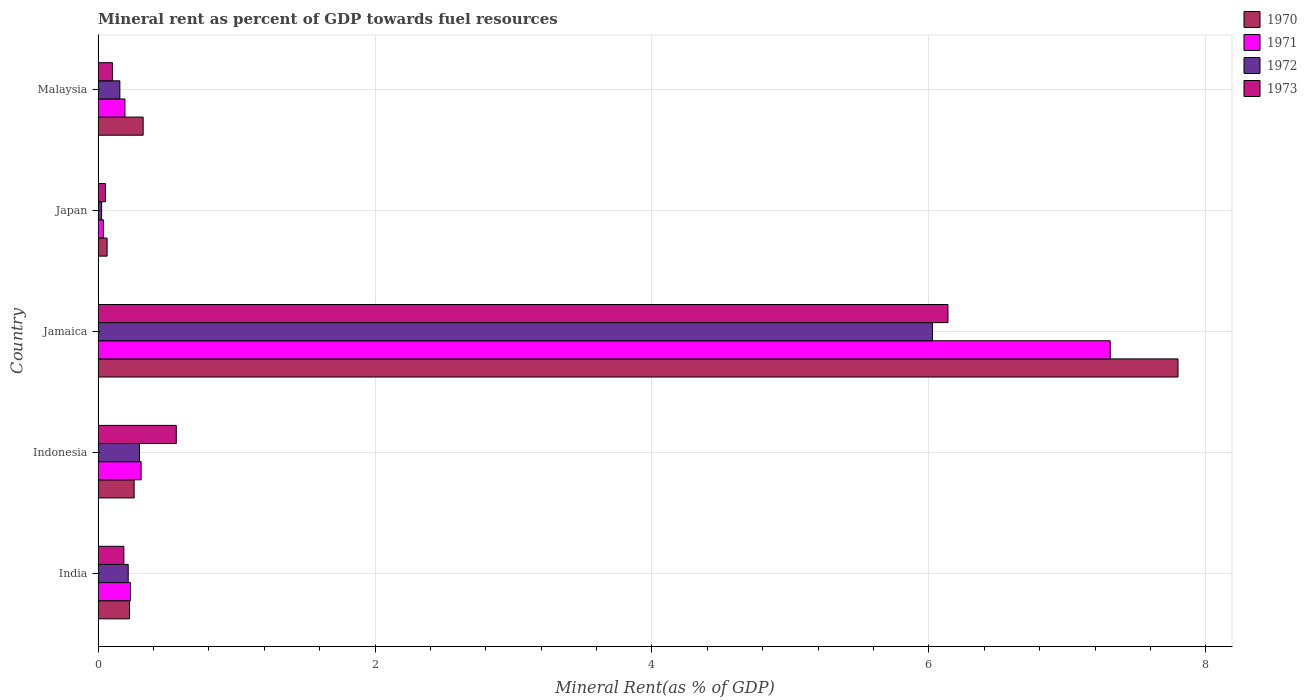How many groups of bars are there?
Your answer should be very brief. 5. Are the number of bars on each tick of the Y-axis equal?
Provide a succinct answer. Yes. How many bars are there on the 2nd tick from the top?
Offer a terse response. 4. What is the mineral rent in 1972 in Indonesia?
Keep it short and to the point. 0.3. Across all countries, what is the maximum mineral rent in 1970?
Keep it short and to the point. 7.8. Across all countries, what is the minimum mineral rent in 1971?
Keep it short and to the point. 0.04. In which country was the mineral rent in 1971 maximum?
Offer a terse response. Jamaica. In which country was the mineral rent in 1973 minimum?
Your answer should be compact. Japan. What is the total mineral rent in 1970 in the graph?
Offer a terse response. 8.68. What is the difference between the mineral rent in 1972 in Indonesia and that in Malaysia?
Your answer should be very brief. 0.14. What is the difference between the mineral rent in 1971 in Jamaica and the mineral rent in 1970 in India?
Your answer should be very brief. 7.08. What is the average mineral rent in 1973 per country?
Your response must be concise. 1.41. What is the difference between the mineral rent in 1972 and mineral rent in 1973 in Jamaica?
Give a very brief answer. -0.11. What is the ratio of the mineral rent in 1970 in India to that in Japan?
Ensure brevity in your answer.  3.5. What is the difference between the highest and the second highest mineral rent in 1972?
Give a very brief answer. 5.73. What is the difference between the highest and the lowest mineral rent in 1970?
Provide a succinct answer. 7.73. Is it the case that in every country, the sum of the mineral rent in 1971 and mineral rent in 1970 is greater than the sum of mineral rent in 1972 and mineral rent in 1973?
Provide a short and direct response. No. What does the 3rd bar from the top in Malaysia represents?
Ensure brevity in your answer.  1971. What does the 3rd bar from the bottom in Japan represents?
Your answer should be compact. 1972. Is it the case that in every country, the sum of the mineral rent in 1971 and mineral rent in 1973 is greater than the mineral rent in 1970?
Make the answer very short. No. How many bars are there?
Offer a terse response. 20. How many countries are there in the graph?
Offer a very short reply. 5. What is the difference between two consecutive major ticks on the X-axis?
Provide a succinct answer. 2. Are the values on the major ticks of X-axis written in scientific E-notation?
Provide a succinct answer. No. Does the graph contain any zero values?
Provide a short and direct response. No. Where does the legend appear in the graph?
Keep it short and to the point. Top right. How are the legend labels stacked?
Your answer should be compact. Vertical. What is the title of the graph?
Keep it short and to the point. Mineral rent as percent of GDP towards fuel resources. Does "1970" appear as one of the legend labels in the graph?
Ensure brevity in your answer.  Yes. What is the label or title of the X-axis?
Your answer should be compact. Mineral Rent(as % of GDP). What is the label or title of the Y-axis?
Give a very brief answer. Country. What is the Mineral Rent(as % of GDP) in 1970 in India?
Offer a very short reply. 0.23. What is the Mineral Rent(as % of GDP) in 1971 in India?
Keep it short and to the point. 0.23. What is the Mineral Rent(as % of GDP) in 1972 in India?
Provide a short and direct response. 0.22. What is the Mineral Rent(as % of GDP) of 1973 in India?
Your answer should be compact. 0.19. What is the Mineral Rent(as % of GDP) of 1970 in Indonesia?
Offer a very short reply. 0.26. What is the Mineral Rent(as % of GDP) in 1971 in Indonesia?
Offer a terse response. 0.31. What is the Mineral Rent(as % of GDP) in 1972 in Indonesia?
Give a very brief answer. 0.3. What is the Mineral Rent(as % of GDP) in 1973 in Indonesia?
Offer a very short reply. 0.56. What is the Mineral Rent(as % of GDP) of 1970 in Jamaica?
Your answer should be very brief. 7.8. What is the Mineral Rent(as % of GDP) in 1971 in Jamaica?
Make the answer very short. 7.31. What is the Mineral Rent(as % of GDP) in 1972 in Jamaica?
Offer a very short reply. 6.03. What is the Mineral Rent(as % of GDP) in 1973 in Jamaica?
Your answer should be compact. 6.14. What is the Mineral Rent(as % of GDP) of 1970 in Japan?
Provide a succinct answer. 0.06. What is the Mineral Rent(as % of GDP) in 1971 in Japan?
Provide a succinct answer. 0.04. What is the Mineral Rent(as % of GDP) of 1972 in Japan?
Your answer should be very brief. 0.03. What is the Mineral Rent(as % of GDP) of 1973 in Japan?
Offer a very short reply. 0.05. What is the Mineral Rent(as % of GDP) in 1970 in Malaysia?
Offer a terse response. 0.33. What is the Mineral Rent(as % of GDP) in 1971 in Malaysia?
Your response must be concise. 0.19. What is the Mineral Rent(as % of GDP) of 1972 in Malaysia?
Give a very brief answer. 0.16. What is the Mineral Rent(as % of GDP) of 1973 in Malaysia?
Offer a very short reply. 0.1. Across all countries, what is the maximum Mineral Rent(as % of GDP) of 1970?
Ensure brevity in your answer.  7.8. Across all countries, what is the maximum Mineral Rent(as % of GDP) of 1971?
Make the answer very short. 7.31. Across all countries, what is the maximum Mineral Rent(as % of GDP) of 1972?
Provide a short and direct response. 6.03. Across all countries, what is the maximum Mineral Rent(as % of GDP) in 1973?
Ensure brevity in your answer.  6.14. Across all countries, what is the minimum Mineral Rent(as % of GDP) in 1970?
Keep it short and to the point. 0.06. Across all countries, what is the minimum Mineral Rent(as % of GDP) of 1971?
Give a very brief answer. 0.04. Across all countries, what is the minimum Mineral Rent(as % of GDP) in 1972?
Give a very brief answer. 0.03. Across all countries, what is the minimum Mineral Rent(as % of GDP) in 1973?
Make the answer very short. 0.05. What is the total Mineral Rent(as % of GDP) of 1970 in the graph?
Keep it short and to the point. 8.68. What is the total Mineral Rent(as % of GDP) in 1971 in the graph?
Offer a very short reply. 8.09. What is the total Mineral Rent(as % of GDP) of 1972 in the graph?
Provide a succinct answer. 6.72. What is the total Mineral Rent(as % of GDP) in 1973 in the graph?
Provide a short and direct response. 7.04. What is the difference between the Mineral Rent(as % of GDP) of 1970 in India and that in Indonesia?
Your answer should be compact. -0.03. What is the difference between the Mineral Rent(as % of GDP) of 1971 in India and that in Indonesia?
Your answer should be compact. -0.08. What is the difference between the Mineral Rent(as % of GDP) in 1972 in India and that in Indonesia?
Your answer should be very brief. -0.08. What is the difference between the Mineral Rent(as % of GDP) in 1973 in India and that in Indonesia?
Your response must be concise. -0.38. What is the difference between the Mineral Rent(as % of GDP) in 1970 in India and that in Jamaica?
Provide a short and direct response. -7.57. What is the difference between the Mineral Rent(as % of GDP) of 1971 in India and that in Jamaica?
Provide a succinct answer. -7.08. What is the difference between the Mineral Rent(as % of GDP) of 1972 in India and that in Jamaica?
Provide a succinct answer. -5.81. What is the difference between the Mineral Rent(as % of GDP) in 1973 in India and that in Jamaica?
Your answer should be compact. -5.95. What is the difference between the Mineral Rent(as % of GDP) of 1970 in India and that in Japan?
Your answer should be compact. 0.16. What is the difference between the Mineral Rent(as % of GDP) of 1971 in India and that in Japan?
Provide a succinct answer. 0.2. What is the difference between the Mineral Rent(as % of GDP) of 1972 in India and that in Japan?
Keep it short and to the point. 0.19. What is the difference between the Mineral Rent(as % of GDP) in 1973 in India and that in Japan?
Give a very brief answer. 0.13. What is the difference between the Mineral Rent(as % of GDP) in 1970 in India and that in Malaysia?
Give a very brief answer. -0.1. What is the difference between the Mineral Rent(as % of GDP) of 1971 in India and that in Malaysia?
Offer a very short reply. 0.04. What is the difference between the Mineral Rent(as % of GDP) of 1972 in India and that in Malaysia?
Offer a very short reply. 0.06. What is the difference between the Mineral Rent(as % of GDP) in 1973 in India and that in Malaysia?
Your response must be concise. 0.08. What is the difference between the Mineral Rent(as % of GDP) of 1970 in Indonesia and that in Jamaica?
Ensure brevity in your answer.  -7.54. What is the difference between the Mineral Rent(as % of GDP) in 1971 in Indonesia and that in Jamaica?
Make the answer very short. -7. What is the difference between the Mineral Rent(as % of GDP) of 1972 in Indonesia and that in Jamaica?
Offer a terse response. -5.73. What is the difference between the Mineral Rent(as % of GDP) in 1973 in Indonesia and that in Jamaica?
Offer a very short reply. -5.57. What is the difference between the Mineral Rent(as % of GDP) of 1970 in Indonesia and that in Japan?
Offer a very short reply. 0.2. What is the difference between the Mineral Rent(as % of GDP) of 1971 in Indonesia and that in Japan?
Ensure brevity in your answer.  0.27. What is the difference between the Mineral Rent(as % of GDP) of 1972 in Indonesia and that in Japan?
Make the answer very short. 0.27. What is the difference between the Mineral Rent(as % of GDP) of 1973 in Indonesia and that in Japan?
Offer a very short reply. 0.51. What is the difference between the Mineral Rent(as % of GDP) in 1970 in Indonesia and that in Malaysia?
Offer a very short reply. -0.07. What is the difference between the Mineral Rent(as % of GDP) in 1971 in Indonesia and that in Malaysia?
Offer a terse response. 0.12. What is the difference between the Mineral Rent(as % of GDP) of 1972 in Indonesia and that in Malaysia?
Provide a succinct answer. 0.14. What is the difference between the Mineral Rent(as % of GDP) in 1973 in Indonesia and that in Malaysia?
Provide a succinct answer. 0.46. What is the difference between the Mineral Rent(as % of GDP) of 1970 in Jamaica and that in Japan?
Keep it short and to the point. 7.73. What is the difference between the Mineral Rent(as % of GDP) in 1971 in Jamaica and that in Japan?
Your answer should be very brief. 7.27. What is the difference between the Mineral Rent(as % of GDP) in 1972 in Jamaica and that in Japan?
Give a very brief answer. 6. What is the difference between the Mineral Rent(as % of GDP) of 1973 in Jamaica and that in Japan?
Give a very brief answer. 6.08. What is the difference between the Mineral Rent(as % of GDP) in 1970 in Jamaica and that in Malaysia?
Give a very brief answer. 7.47. What is the difference between the Mineral Rent(as % of GDP) of 1971 in Jamaica and that in Malaysia?
Your answer should be compact. 7.12. What is the difference between the Mineral Rent(as % of GDP) of 1972 in Jamaica and that in Malaysia?
Provide a succinct answer. 5.87. What is the difference between the Mineral Rent(as % of GDP) of 1973 in Jamaica and that in Malaysia?
Offer a very short reply. 6.03. What is the difference between the Mineral Rent(as % of GDP) in 1970 in Japan and that in Malaysia?
Your answer should be very brief. -0.26. What is the difference between the Mineral Rent(as % of GDP) of 1971 in Japan and that in Malaysia?
Offer a very short reply. -0.16. What is the difference between the Mineral Rent(as % of GDP) in 1972 in Japan and that in Malaysia?
Give a very brief answer. -0.13. What is the difference between the Mineral Rent(as % of GDP) in 1973 in Japan and that in Malaysia?
Offer a terse response. -0.05. What is the difference between the Mineral Rent(as % of GDP) of 1970 in India and the Mineral Rent(as % of GDP) of 1971 in Indonesia?
Your response must be concise. -0.08. What is the difference between the Mineral Rent(as % of GDP) of 1970 in India and the Mineral Rent(as % of GDP) of 1972 in Indonesia?
Offer a very short reply. -0.07. What is the difference between the Mineral Rent(as % of GDP) in 1970 in India and the Mineral Rent(as % of GDP) in 1973 in Indonesia?
Your response must be concise. -0.34. What is the difference between the Mineral Rent(as % of GDP) of 1971 in India and the Mineral Rent(as % of GDP) of 1972 in Indonesia?
Provide a succinct answer. -0.07. What is the difference between the Mineral Rent(as % of GDP) in 1971 in India and the Mineral Rent(as % of GDP) in 1973 in Indonesia?
Offer a terse response. -0.33. What is the difference between the Mineral Rent(as % of GDP) in 1972 in India and the Mineral Rent(as % of GDP) in 1973 in Indonesia?
Your answer should be compact. -0.35. What is the difference between the Mineral Rent(as % of GDP) of 1970 in India and the Mineral Rent(as % of GDP) of 1971 in Jamaica?
Ensure brevity in your answer.  -7.08. What is the difference between the Mineral Rent(as % of GDP) in 1970 in India and the Mineral Rent(as % of GDP) in 1972 in Jamaica?
Keep it short and to the point. -5.8. What is the difference between the Mineral Rent(as % of GDP) of 1970 in India and the Mineral Rent(as % of GDP) of 1973 in Jamaica?
Make the answer very short. -5.91. What is the difference between the Mineral Rent(as % of GDP) in 1971 in India and the Mineral Rent(as % of GDP) in 1972 in Jamaica?
Your response must be concise. -5.79. What is the difference between the Mineral Rent(as % of GDP) of 1971 in India and the Mineral Rent(as % of GDP) of 1973 in Jamaica?
Provide a succinct answer. -5.9. What is the difference between the Mineral Rent(as % of GDP) in 1972 in India and the Mineral Rent(as % of GDP) in 1973 in Jamaica?
Provide a succinct answer. -5.92. What is the difference between the Mineral Rent(as % of GDP) in 1970 in India and the Mineral Rent(as % of GDP) in 1971 in Japan?
Provide a short and direct response. 0.19. What is the difference between the Mineral Rent(as % of GDP) of 1970 in India and the Mineral Rent(as % of GDP) of 1972 in Japan?
Offer a terse response. 0.2. What is the difference between the Mineral Rent(as % of GDP) in 1970 in India and the Mineral Rent(as % of GDP) in 1973 in Japan?
Keep it short and to the point. 0.17. What is the difference between the Mineral Rent(as % of GDP) of 1971 in India and the Mineral Rent(as % of GDP) of 1972 in Japan?
Keep it short and to the point. 0.21. What is the difference between the Mineral Rent(as % of GDP) of 1971 in India and the Mineral Rent(as % of GDP) of 1973 in Japan?
Make the answer very short. 0.18. What is the difference between the Mineral Rent(as % of GDP) in 1972 in India and the Mineral Rent(as % of GDP) in 1973 in Japan?
Keep it short and to the point. 0.16. What is the difference between the Mineral Rent(as % of GDP) in 1970 in India and the Mineral Rent(as % of GDP) in 1972 in Malaysia?
Your response must be concise. 0.07. What is the difference between the Mineral Rent(as % of GDP) in 1970 in India and the Mineral Rent(as % of GDP) in 1973 in Malaysia?
Make the answer very short. 0.12. What is the difference between the Mineral Rent(as % of GDP) of 1971 in India and the Mineral Rent(as % of GDP) of 1972 in Malaysia?
Provide a succinct answer. 0.08. What is the difference between the Mineral Rent(as % of GDP) of 1971 in India and the Mineral Rent(as % of GDP) of 1973 in Malaysia?
Provide a short and direct response. 0.13. What is the difference between the Mineral Rent(as % of GDP) of 1972 in India and the Mineral Rent(as % of GDP) of 1973 in Malaysia?
Give a very brief answer. 0.11. What is the difference between the Mineral Rent(as % of GDP) in 1970 in Indonesia and the Mineral Rent(as % of GDP) in 1971 in Jamaica?
Give a very brief answer. -7.05. What is the difference between the Mineral Rent(as % of GDP) in 1970 in Indonesia and the Mineral Rent(as % of GDP) in 1972 in Jamaica?
Your answer should be very brief. -5.77. What is the difference between the Mineral Rent(as % of GDP) of 1970 in Indonesia and the Mineral Rent(as % of GDP) of 1973 in Jamaica?
Keep it short and to the point. -5.88. What is the difference between the Mineral Rent(as % of GDP) in 1971 in Indonesia and the Mineral Rent(as % of GDP) in 1972 in Jamaica?
Offer a very short reply. -5.72. What is the difference between the Mineral Rent(as % of GDP) in 1971 in Indonesia and the Mineral Rent(as % of GDP) in 1973 in Jamaica?
Your response must be concise. -5.83. What is the difference between the Mineral Rent(as % of GDP) in 1972 in Indonesia and the Mineral Rent(as % of GDP) in 1973 in Jamaica?
Give a very brief answer. -5.84. What is the difference between the Mineral Rent(as % of GDP) of 1970 in Indonesia and the Mineral Rent(as % of GDP) of 1971 in Japan?
Give a very brief answer. 0.22. What is the difference between the Mineral Rent(as % of GDP) of 1970 in Indonesia and the Mineral Rent(as % of GDP) of 1972 in Japan?
Offer a very short reply. 0.23. What is the difference between the Mineral Rent(as % of GDP) of 1970 in Indonesia and the Mineral Rent(as % of GDP) of 1973 in Japan?
Keep it short and to the point. 0.21. What is the difference between the Mineral Rent(as % of GDP) in 1971 in Indonesia and the Mineral Rent(as % of GDP) in 1972 in Japan?
Offer a terse response. 0.29. What is the difference between the Mineral Rent(as % of GDP) in 1971 in Indonesia and the Mineral Rent(as % of GDP) in 1973 in Japan?
Make the answer very short. 0.26. What is the difference between the Mineral Rent(as % of GDP) of 1972 in Indonesia and the Mineral Rent(as % of GDP) of 1973 in Japan?
Your answer should be very brief. 0.25. What is the difference between the Mineral Rent(as % of GDP) of 1970 in Indonesia and the Mineral Rent(as % of GDP) of 1971 in Malaysia?
Offer a very short reply. 0.07. What is the difference between the Mineral Rent(as % of GDP) of 1970 in Indonesia and the Mineral Rent(as % of GDP) of 1972 in Malaysia?
Offer a terse response. 0.1. What is the difference between the Mineral Rent(as % of GDP) of 1970 in Indonesia and the Mineral Rent(as % of GDP) of 1973 in Malaysia?
Offer a very short reply. 0.16. What is the difference between the Mineral Rent(as % of GDP) in 1971 in Indonesia and the Mineral Rent(as % of GDP) in 1972 in Malaysia?
Give a very brief answer. 0.15. What is the difference between the Mineral Rent(as % of GDP) of 1971 in Indonesia and the Mineral Rent(as % of GDP) of 1973 in Malaysia?
Ensure brevity in your answer.  0.21. What is the difference between the Mineral Rent(as % of GDP) in 1972 in Indonesia and the Mineral Rent(as % of GDP) in 1973 in Malaysia?
Your answer should be compact. 0.2. What is the difference between the Mineral Rent(as % of GDP) in 1970 in Jamaica and the Mineral Rent(as % of GDP) in 1971 in Japan?
Provide a succinct answer. 7.76. What is the difference between the Mineral Rent(as % of GDP) in 1970 in Jamaica and the Mineral Rent(as % of GDP) in 1972 in Japan?
Your answer should be compact. 7.77. What is the difference between the Mineral Rent(as % of GDP) in 1970 in Jamaica and the Mineral Rent(as % of GDP) in 1973 in Japan?
Ensure brevity in your answer.  7.75. What is the difference between the Mineral Rent(as % of GDP) of 1971 in Jamaica and the Mineral Rent(as % of GDP) of 1972 in Japan?
Ensure brevity in your answer.  7.28. What is the difference between the Mineral Rent(as % of GDP) of 1971 in Jamaica and the Mineral Rent(as % of GDP) of 1973 in Japan?
Give a very brief answer. 7.26. What is the difference between the Mineral Rent(as % of GDP) in 1972 in Jamaica and the Mineral Rent(as % of GDP) in 1973 in Japan?
Your answer should be very brief. 5.97. What is the difference between the Mineral Rent(as % of GDP) in 1970 in Jamaica and the Mineral Rent(as % of GDP) in 1971 in Malaysia?
Offer a very short reply. 7.61. What is the difference between the Mineral Rent(as % of GDP) in 1970 in Jamaica and the Mineral Rent(as % of GDP) in 1972 in Malaysia?
Provide a succinct answer. 7.64. What is the difference between the Mineral Rent(as % of GDP) in 1970 in Jamaica and the Mineral Rent(as % of GDP) in 1973 in Malaysia?
Make the answer very short. 7.7. What is the difference between the Mineral Rent(as % of GDP) of 1971 in Jamaica and the Mineral Rent(as % of GDP) of 1972 in Malaysia?
Offer a very short reply. 7.15. What is the difference between the Mineral Rent(as % of GDP) of 1971 in Jamaica and the Mineral Rent(as % of GDP) of 1973 in Malaysia?
Offer a terse response. 7.21. What is the difference between the Mineral Rent(as % of GDP) in 1972 in Jamaica and the Mineral Rent(as % of GDP) in 1973 in Malaysia?
Give a very brief answer. 5.92. What is the difference between the Mineral Rent(as % of GDP) in 1970 in Japan and the Mineral Rent(as % of GDP) in 1971 in Malaysia?
Keep it short and to the point. -0.13. What is the difference between the Mineral Rent(as % of GDP) in 1970 in Japan and the Mineral Rent(as % of GDP) in 1972 in Malaysia?
Offer a terse response. -0.09. What is the difference between the Mineral Rent(as % of GDP) of 1970 in Japan and the Mineral Rent(as % of GDP) of 1973 in Malaysia?
Provide a short and direct response. -0.04. What is the difference between the Mineral Rent(as % of GDP) in 1971 in Japan and the Mineral Rent(as % of GDP) in 1972 in Malaysia?
Make the answer very short. -0.12. What is the difference between the Mineral Rent(as % of GDP) of 1971 in Japan and the Mineral Rent(as % of GDP) of 1973 in Malaysia?
Offer a very short reply. -0.06. What is the difference between the Mineral Rent(as % of GDP) in 1972 in Japan and the Mineral Rent(as % of GDP) in 1973 in Malaysia?
Ensure brevity in your answer.  -0.08. What is the average Mineral Rent(as % of GDP) of 1970 per country?
Make the answer very short. 1.74. What is the average Mineral Rent(as % of GDP) of 1971 per country?
Ensure brevity in your answer.  1.62. What is the average Mineral Rent(as % of GDP) in 1972 per country?
Ensure brevity in your answer.  1.34. What is the average Mineral Rent(as % of GDP) in 1973 per country?
Offer a terse response. 1.41. What is the difference between the Mineral Rent(as % of GDP) of 1970 and Mineral Rent(as % of GDP) of 1971 in India?
Offer a very short reply. -0.01. What is the difference between the Mineral Rent(as % of GDP) in 1970 and Mineral Rent(as % of GDP) in 1972 in India?
Your response must be concise. 0.01. What is the difference between the Mineral Rent(as % of GDP) in 1970 and Mineral Rent(as % of GDP) in 1973 in India?
Make the answer very short. 0.04. What is the difference between the Mineral Rent(as % of GDP) of 1971 and Mineral Rent(as % of GDP) of 1972 in India?
Your answer should be compact. 0.02. What is the difference between the Mineral Rent(as % of GDP) in 1971 and Mineral Rent(as % of GDP) in 1973 in India?
Offer a terse response. 0.05. What is the difference between the Mineral Rent(as % of GDP) in 1972 and Mineral Rent(as % of GDP) in 1973 in India?
Provide a succinct answer. 0.03. What is the difference between the Mineral Rent(as % of GDP) of 1970 and Mineral Rent(as % of GDP) of 1971 in Indonesia?
Offer a very short reply. -0.05. What is the difference between the Mineral Rent(as % of GDP) of 1970 and Mineral Rent(as % of GDP) of 1972 in Indonesia?
Ensure brevity in your answer.  -0.04. What is the difference between the Mineral Rent(as % of GDP) of 1970 and Mineral Rent(as % of GDP) of 1973 in Indonesia?
Offer a terse response. -0.3. What is the difference between the Mineral Rent(as % of GDP) in 1971 and Mineral Rent(as % of GDP) in 1972 in Indonesia?
Your answer should be very brief. 0.01. What is the difference between the Mineral Rent(as % of GDP) in 1971 and Mineral Rent(as % of GDP) in 1973 in Indonesia?
Make the answer very short. -0.25. What is the difference between the Mineral Rent(as % of GDP) of 1972 and Mineral Rent(as % of GDP) of 1973 in Indonesia?
Keep it short and to the point. -0.27. What is the difference between the Mineral Rent(as % of GDP) of 1970 and Mineral Rent(as % of GDP) of 1971 in Jamaica?
Keep it short and to the point. 0.49. What is the difference between the Mineral Rent(as % of GDP) in 1970 and Mineral Rent(as % of GDP) in 1972 in Jamaica?
Keep it short and to the point. 1.77. What is the difference between the Mineral Rent(as % of GDP) in 1970 and Mineral Rent(as % of GDP) in 1973 in Jamaica?
Keep it short and to the point. 1.66. What is the difference between the Mineral Rent(as % of GDP) in 1971 and Mineral Rent(as % of GDP) in 1972 in Jamaica?
Offer a terse response. 1.28. What is the difference between the Mineral Rent(as % of GDP) in 1971 and Mineral Rent(as % of GDP) in 1973 in Jamaica?
Provide a short and direct response. 1.17. What is the difference between the Mineral Rent(as % of GDP) in 1972 and Mineral Rent(as % of GDP) in 1973 in Jamaica?
Offer a very short reply. -0.11. What is the difference between the Mineral Rent(as % of GDP) of 1970 and Mineral Rent(as % of GDP) of 1971 in Japan?
Ensure brevity in your answer.  0.03. What is the difference between the Mineral Rent(as % of GDP) of 1970 and Mineral Rent(as % of GDP) of 1972 in Japan?
Keep it short and to the point. 0.04. What is the difference between the Mineral Rent(as % of GDP) of 1970 and Mineral Rent(as % of GDP) of 1973 in Japan?
Keep it short and to the point. 0.01. What is the difference between the Mineral Rent(as % of GDP) in 1971 and Mineral Rent(as % of GDP) in 1972 in Japan?
Ensure brevity in your answer.  0.01. What is the difference between the Mineral Rent(as % of GDP) in 1971 and Mineral Rent(as % of GDP) in 1973 in Japan?
Your response must be concise. -0.01. What is the difference between the Mineral Rent(as % of GDP) of 1972 and Mineral Rent(as % of GDP) of 1973 in Japan?
Ensure brevity in your answer.  -0.03. What is the difference between the Mineral Rent(as % of GDP) of 1970 and Mineral Rent(as % of GDP) of 1971 in Malaysia?
Your answer should be very brief. 0.13. What is the difference between the Mineral Rent(as % of GDP) of 1970 and Mineral Rent(as % of GDP) of 1972 in Malaysia?
Your response must be concise. 0.17. What is the difference between the Mineral Rent(as % of GDP) in 1970 and Mineral Rent(as % of GDP) in 1973 in Malaysia?
Ensure brevity in your answer.  0.22. What is the difference between the Mineral Rent(as % of GDP) in 1971 and Mineral Rent(as % of GDP) in 1972 in Malaysia?
Provide a short and direct response. 0.04. What is the difference between the Mineral Rent(as % of GDP) in 1971 and Mineral Rent(as % of GDP) in 1973 in Malaysia?
Provide a succinct answer. 0.09. What is the difference between the Mineral Rent(as % of GDP) in 1972 and Mineral Rent(as % of GDP) in 1973 in Malaysia?
Make the answer very short. 0.05. What is the ratio of the Mineral Rent(as % of GDP) of 1970 in India to that in Indonesia?
Provide a succinct answer. 0.87. What is the ratio of the Mineral Rent(as % of GDP) in 1971 in India to that in Indonesia?
Provide a short and direct response. 0.75. What is the ratio of the Mineral Rent(as % of GDP) of 1972 in India to that in Indonesia?
Provide a short and direct response. 0.73. What is the ratio of the Mineral Rent(as % of GDP) of 1973 in India to that in Indonesia?
Offer a terse response. 0.33. What is the ratio of the Mineral Rent(as % of GDP) in 1970 in India to that in Jamaica?
Give a very brief answer. 0.03. What is the ratio of the Mineral Rent(as % of GDP) in 1971 in India to that in Jamaica?
Your answer should be compact. 0.03. What is the ratio of the Mineral Rent(as % of GDP) of 1972 in India to that in Jamaica?
Make the answer very short. 0.04. What is the ratio of the Mineral Rent(as % of GDP) in 1973 in India to that in Jamaica?
Give a very brief answer. 0.03. What is the ratio of the Mineral Rent(as % of GDP) in 1970 in India to that in Japan?
Your answer should be compact. 3.5. What is the ratio of the Mineral Rent(as % of GDP) of 1971 in India to that in Japan?
Ensure brevity in your answer.  6.06. What is the ratio of the Mineral Rent(as % of GDP) in 1972 in India to that in Japan?
Give a very brief answer. 8.6. What is the ratio of the Mineral Rent(as % of GDP) in 1973 in India to that in Japan?
Provide a succinct answer. 3.52. What is the ratio of the Mineral Rent(as % of GDP) of 1970 in India to that in Malaysia?
Provide a succinct answer. 0.7. What is the ratio of the Mineral Rent(as % of GDP) in 1971 in India to that in Malaysia?
Your answer should be very brief. 1.21. What is the ratio of the Mineral Rent(as % of GDP) in 1972 in India to that in Malaysia?
Your response must be concise. 1.38. What is the ratio of the Mineral Rent(as % of GDP) of 1973 in India to that in Malaysia?
Your answer should be compact. 1.8. What is the ratio of the Mineral Rent(as % of GDP) in 1970 in Indonesia to that in Jamaica?
Provide a short and direct response. 0.03. What is the ratio of the Mineral Rent(as % of GDP) of 1971 in Indonesia to that in Jamaica?
Ensure brevity in your answer.  0.04. What is the ratio of the Mineral Rent(as % of GDP) in 1972 in Indonesia to that in Jamaica?
Offer a very short reply. 0.05. What is the ratio of the Mineral Rent(as % of GDP) of 1973 in Indonesia to that in Jamaica?
Make the answer very short. 0.09. What is the ratio of the Mineral Rent(as % of GDP) in 1970 in Indonesia to that in Japan?
Provide a succinct answer. 4.01. What is the ratio of the Mineral Rent(as % of GDP) in 1971 in Indonesia to that in Japan?
Your answer should be compact. 8.06. What is the ratio of the Mineral Rent(as % of GDP) of 1972 in Indonesia to that in Japan?
Ensure brevity in your answer.  11.82. What is the ratio of the Mineral Rent(as % of GDP) in 1973 in Indonesia to that in Japan?
Make the answer very short. 10.69. What is the ratio of the Mineral Rent(as % of GDP) of 1970 in Indonesia to that in Malaysia?
Keep it short and to the point. 0.8. What is the ratio of the Mineral Rent(as % of GDP) in 1971 in Indonesia to that in Malaysia?
Make the answer very short. 1.6. What is the ratio of the Mineral Rent(as % of GDP) of 1972 in Indonesia to that in Malaysia?
Keep it short and to the point. 1.9. What is the ratio of the Mineral Rent(as % of GDP) of 1973 in Indonesia to that in Malaysia?
Provide a succinct answer. 5.47. What is the ratio of the Mineral Rent(as % of GDP) of 1970 in Jamaica to that in Japan?
Offer a terse response. 120.23. What is the ratio of the Mineral Rent(as % of GDP) of 1971 in Jamaica to that in Japan?
Your answer should be very brief. 189.73. What is the ratio of the Mineral Rent(as % of GDP) in 1972 in Jamaica to that in Japan?
Provide a succinct answer. 238.51. What is the ratio of the Mineral Rent(as % of GDP) in 1973 in Jamaica to that in Japan?
Offer a very short reply. 116.18. What is the ratio of the Mineral Rent(as % of GDP) of 1970 in Jamaica to that in Malaysia?
Offer a very short reply. 23.97. What is the ratio of the Mineral Rent(as % of GDP) of 1971 in Jamaica to that in Malaysia?
Offer a terse response. 37.76. What is the ratio of the Mineral Rent(as % of GDP) in 1972 in Jamaica to that in Malaysia?
Your answer should be very brief. 38.36. What is the ratio of the Mineral Rent(as % of GDP) of 1973 in Jamaica to that in Malaysia?
Offer a very short reply. 59.49. What is the ratio of the Mineral Rent(as % of GDP) of 1970 in Japan to that in Malaysia?
Ensure brevity in your answer.  0.2. What is the ratio of the Mineral Rent(as % of GDP) in 1971 in Japan to that in Malaysia?
Your response must be concise. 0.2. What is the ratio of the Mineral Rent(as % of GDP) in 1972 in Japan to that in Malaysia?
Offer a very short reply. 0.16. What is the ratio of the Mineral Rent(as % of GDP) in 1973 in Japan to that in Malaysia?
Offer a terse response. 0.51. What is the difference between the highest and the second highest Mineral Rent(as % of GDP) in 1970?
Give a very brief answer. 7.47. What is the difference between the highest and the second highest Mineral Rent(as % of GDP) in 1971?
Make the answer very short. 7. What is the difference between the highest and the second highest Mineral Rent(as % of GDP) in 1972?
Give a very brief answer. 5.73. What is the difference between the highest and the second highest Mineral Rent(as % of GDP) in 1973?
Keep it short and to the point. 5.57. What is the difference between the highest and the lowest Mineral Rent(as % of GDP) in 1970?
Your answer should be compact. 7.73. What is the difference between the highest and the lowest Mineral Rent(as % of GDP) of 1971?
Your response must be concise. 7.27. What is the difference between the highest and the lowest Mineral Rent(as % of GDP) in 1972?
Offer a terse response. 6. What is the difference between the highest and the lowest Mineral Rent(as % of GDP) in 1973?
Offer a terse response. 6.08. 